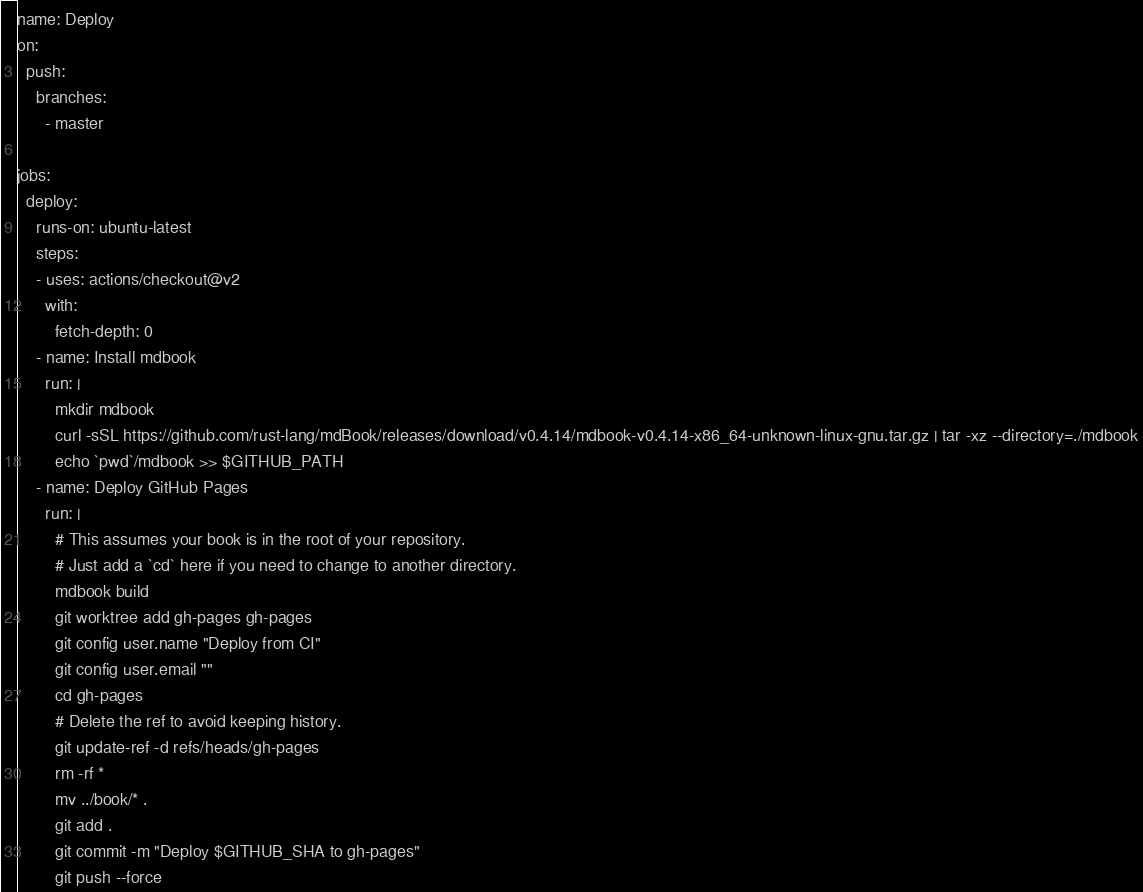<code> <loc_0><loc_0><loc_500><loc_500><_YAML_>name: Deploy
on:
  push:
    branches:
      - master

jobs:
  deploy:
    runs-on: ubuntu-latest
    steps:
    - uses: actions/checkout@v2
      with:
        fetch-depth: 0
    - name: Install mdbook
      run: |
        mkdir mdbook
        curl -sSL https://github.com/rust-lang/mdBook/releases/download/v0.4.14/mdbook-v0.4.14-x86_64-unknown-linux-gnu.tar.gz | tar -xz --directory=./mdbook
        echo `pwd`/mdbook >> $GITHUB_PATH
    - name: Deploy GitHub Pages
      run: |
        # This assumes your book is in the root of your repository.
        # Just add a `cd` here if you need to change to another directory.
        mdbook build
        git worktree add gh-pages gh-pages
        git config user.name "Deploy from CI"
        git config user.email ""
        cd gh-pages
        # Delete the ref to avoid keeping history.
        git update-ref -d refs/heads/gh-pages
        rm -rf *
        mv ../book/* .
        git add .
        git commit -m "Deploy $GITHUB_SHA to gh-pages"
        git push --force
</code> 